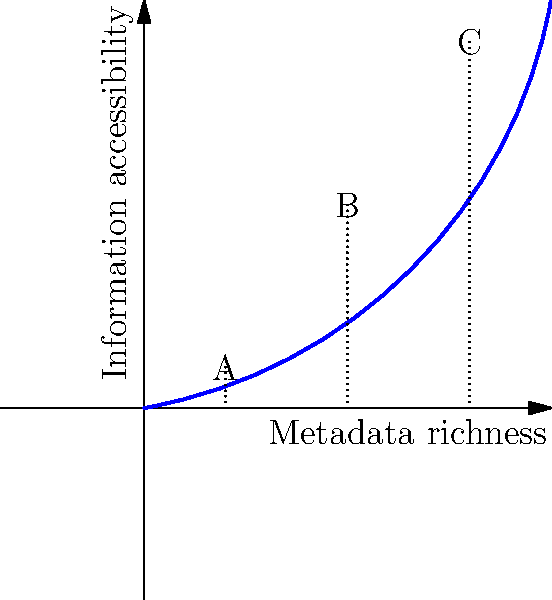The diagram illustrates the relationship between metadata richness and information accessibility in an information retrieval system. Points A, B, and C represent different levels of metadata implementation. Which point likely represents the most efficient balance between metadata richness and information accessibility, and why? To determine the most efficient balance between metadata richness and information accessibility, we need to analyze the curve and the three points:

1. The x-axis represents metadata richness, increasing from left to right.
2. The y-axis represents information accessibility, increasing from bottom to top.
3. The curve shows a positive correlation between metadata richness and information accessibility.
4. Point A has low metadata richness and low accessibility.
5. Point C has high metadata richness and high accessibility.
6. Point B is in the middle of the curve.

The relationship is not linear, but follows a curve with diminishing returns. This means:

7. Initially, small increases in metadata richness lead to significant improvements in accessibility (steep curve near point A).
8. As metadata richness increases, the rate of improvement in accessibility slows down (curve flattens near point C).
9. Point B is located at the "elbow" of the curve, where the rate of change starts to decrease significantly.

Therefore, point B likely represents the most efficient balance because:

10. It provides a substantial improvement in accessibility compared to point A.
11. It requires less investment in metadata richness compared to point C.
12. The marginal benefit of increasing metadata richness beyond point B diminishes, making further investments less cost-effective.
Answer: Point B 